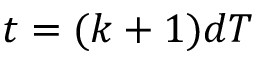Convert formula to latex. <formula><loc_0><loc_0><loc_500><loc_500>t = ( k + 1 ) d T</formula> 